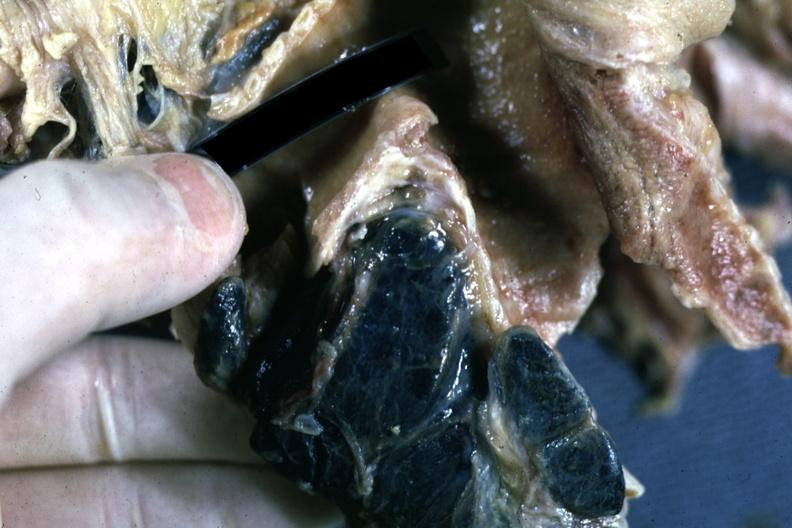what does this image show?
Answer the question using a single word or phrase. Fixed tissue sectioned carinal nodes shown close-up nodes are filled with black pigment 